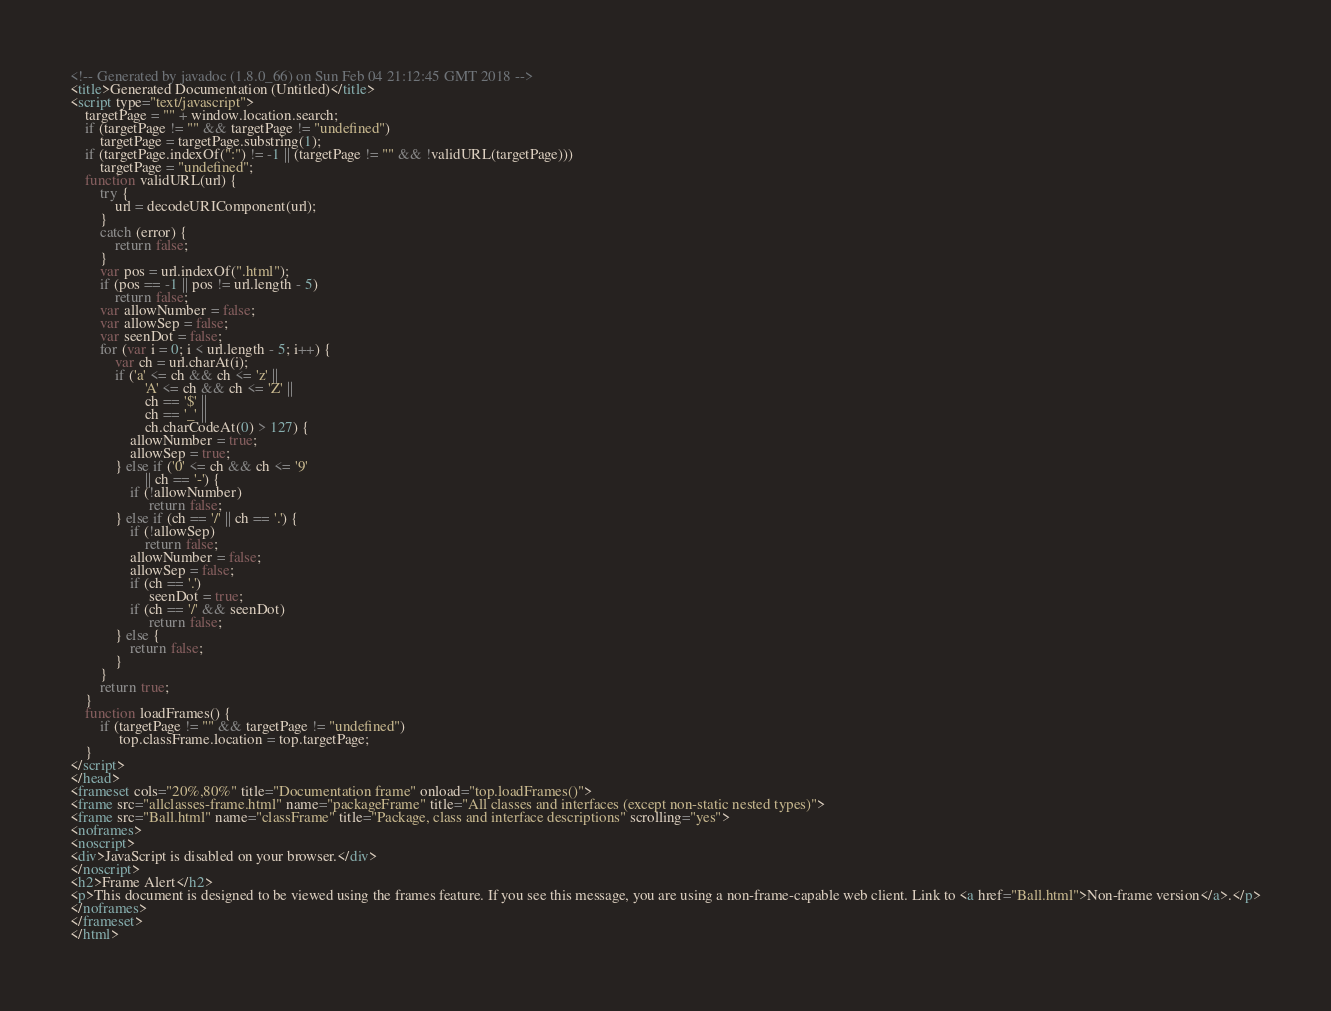<code> <loc_0><loc_0><loc_500><loc_500><_HTML_><!-- Generated by javadoc (1.8.0_66) on Sun Feb 04 21:12:45 GMT 2018 -->
<title>Generated Documentation (Untitled)</title>
<script type="text/javascript">
    targetPage = "" + window.location.search;
    if (targetPage != "" && targetPage != "undefined")
        targetPage = targetPage.substring(1);
    if (targetPage.indexOf(":") != -1 || (targetPage != "" && !validURL(targetPage)))
        targetPage = "undefined";
    function validURL(url) {
        try {
            url = decodeURIComponent(url);
        }
        catch (error) {
            return false;
        }
        var pos = url.indexOf(".html");
        if (pos == -1 || pos != url.length - 5)
            return false;
        var allowNumber = false;
        var allowSep = false;
        var seenDot = false;
        for (var i = 0; i < url.length - 5; i++) {
            var ch = url.charAt(i);
            if ('a' <= ch && ch <= 'z' ||
                    'A' <= ch && ch <= 'Z' ||
                    ch == '$' ||
                    ch == '_' ||
                    ch.charCodeAt(0) > 127) {
                allowNumber = true;
                allowSep = true;
            } else if ('0' <= ch && ch <= '9'
                    || ch == '-') {
                if (!allowNumber)
                     return false;
            } else if (ch == '/' || ch == '.') {
                if (!allowSep)
                    return false;
                allowNumber = false;
                allowSep = false;
                if (ch == '.')
                     seenDot = true;
                if (ch == '/' && seenDot)
                     return false;
            } else {
                return false;
            }
        }
        return true;
    }
    function loadFrames() {
        if (targetPage != "" && targetPage != "undefined")
             top.classFrame.location = top.targetPage;
    }
</script>
</head>
<frameset cols="20%,80%" title="Documentation frame" onload="top.loadFrames()">
<frame src="allclasses-frame.html" name="packageFrame" title="All classes and interfaces (except non-static nested types)">
<frame src="Ball.html" name="classFrame" title="Package, class and interface descriptions" scrolling="yes">
<noframes>
<noscript>
<div>JavaScript is disabled on your browser.</div>
</noscript>
<h2>Frame Alert</h2>
<p>This document is designed to be viewed using the frames feature. If you see this message, you are using a non-frame-capable web client. Link to <a href="Ball.html">Non-frame version</a>.</p>
</noframes>
</frameset>
</html>
</code> 